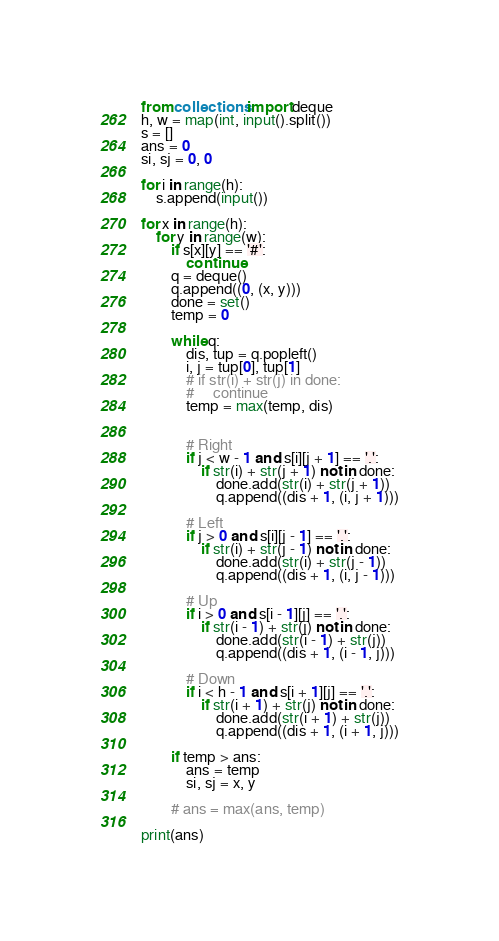Convert code to text. <code><loc_0><loc_0><loc_500><loc_500><_Python_>from collections import deque
h, w = map(int, input().split())
s = []
ans = 0
si, sj = 0, 0

for i in range(h):
    s.append(input())

for x in range(h):
    for y in range(w):
        if s[x][y] == '#':
            continue
        q = deque()
        q.append((0, (x, y)))
        done = set()
        temp = 0

        while q:
            dis, tup = q.popleft()
            i, j = tup[0], tup[1]
            # if str(i) + str(j) in done:
            #     continue
            temp = max(temp, dis)


            # Right
            if j < w - 1 and s[i][j + 1] == '.':
                if str(i) + str(j + 1) not in done:
                    done.add(str(i) + str(j + 1))
                    q.append((dis + 1, (i, j + 1)))

            # Left
            if j > 0 and s[i][j - 1] == '.':
                if str(i) + str(j - 1) not in done:
                    done.add(str(i) + str(j - 1))
                    q.append((dis + 1, (i, j - 1)))

            # Up
            if i > 0 and s[i - 1][j] == '.':
                if str(i - 1) + str(j) not in done:
                    done.add(str(i - 1) + str(j))
                    q.append((dis + 1, (i - 1, j)))

            # Down
            if i < h - 1 and s[i + 1][j] == '.':
                if str(i + 1) + str(j) not in done:
                    done.add(str(i + 1) + str(j))
                    q.append((dis + 1, (i + 1, j)))

        if temp > ans:
            ans = temp
            si, sj = x, y

        # ans = max(ans, temp)

print(ans)</code> 